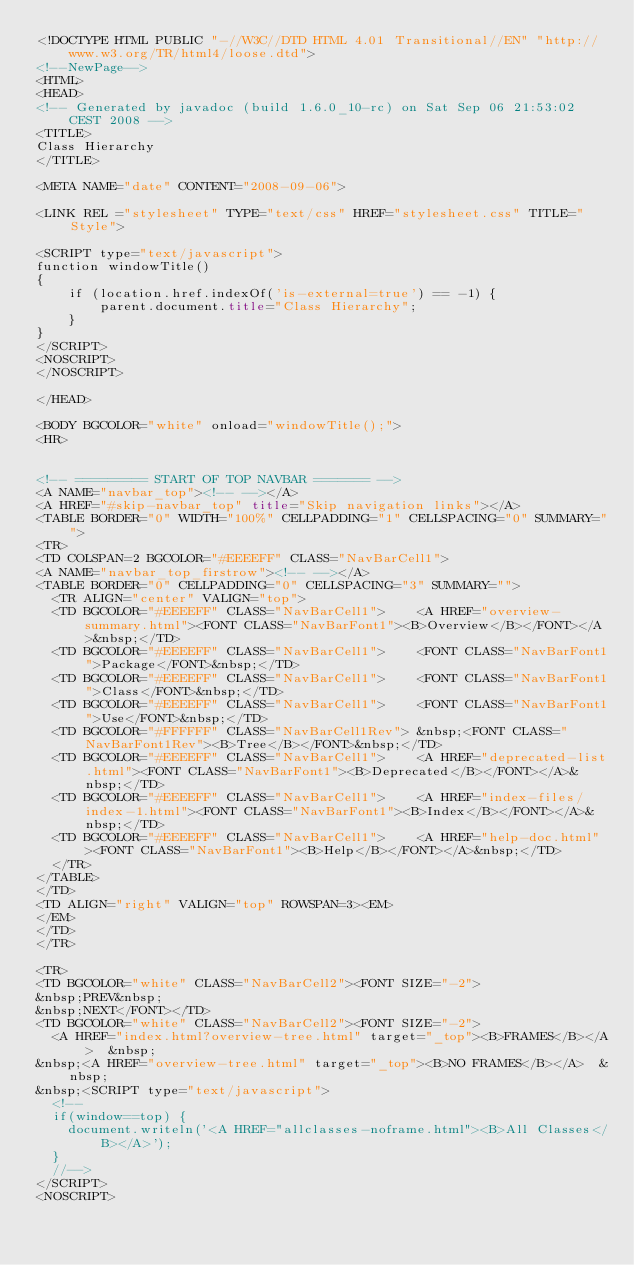Convert code to text. <code><loc_0><loc_0><loc_500><loc_500><_HTML_><!DOCTYPE HTML PUBLIC "-//W3C//DTD HTML 4.01 Transitional//EN" "http://www.w3.org/TR/html4/loose.dtd">
<!--NewPage-->
<HTML>
<HEAD>
<!-- Generated by javadoc (build 1.6.0_10-rc) on Sat Sep 06 21:53:02 CEST 2008 -->
<TITLE>
Class Hierarchy
</TITLE>

<META NAME="date" CONTENT="2008-09-06">

<LINK REL ="stylesheet" TYPE="text/css" HREF="stylesheet.css" TITLE="Style">

<SCRIPT type="text/javascript">
function windowTitle()
{
    if (location.href.indexOf('is-external=true') == -1) {
        parent.document.title="Class Hierarchy";
    }
}
</SCRIPT>
<NOSCRIPT>
</NOSCRIPT>

</HEAD>

<BODY BGCOLOR="white" onload="windowTitle();">
<HR>


<!-- ========= START OF TOP NAVBAR ======= -->
<A NAME="navbar_top"><!-- --></A>
<A HREF="#skip-navbar_top" title="Skip navigation links"></A>
<TABLE BORDER="0" WIDTH="100%" CELLPADDING="1" CELLSPACING="0" SUMMARY="">
<TR>
<TD COLSPAN=2 BGCOLOR="#EEEEFF" CLASS="NavBarCell1">
<A NAME="navbar_top_firstrow"><!-- --></A>
<TABLE BORDER="0" CELLPADDING="0" CELLSPACING="3" SUMMARY="">
  <TR ALIGN="center" VALIGN="top">
  <TD BGCOLOR="#EEEEFF" CLASS="NavBarCell1">    <A HREF="overview-summary.html"><FONT CLASS="NavBarFont1"><B>Overview</B></FONT></A>&nbsp;</TD>
  <TD BGCOLOR="#EEEEFF" CLASS="NavBarCell1">    <FONT CLASS="NavBarFont1">Package</FONT>&nbsp;</TD>
  <TD BGCOLOR="#EEEEFF" CLASS="NavBarCell1">    <FONT CLASS="NavBarFont1">Class</FONT>&nbsp;</TD>
  <TD BGCOLOR="#EEEEFF" CLASS="NavBarCell1">    <FONT CLASS="NavBarFont1">Use</FONT>&nbsp;</TD>
  <TD BGCOLOR="#FFFFFF" CLASS="NavBarCell1Rev"> &nbsp;<FONT CLASS="NavBarFont1Rev"><B>Tree</B></FONT>&nbsp;</TD>
  <TD BGCOLOR="#EEEEFF" CLASS="NavBarCell1">    <A HREF="deprecated-list.html"><FONT CLASS="NavBarFont1"><B>Deprecated</B></FONT></A>&nbsp;</TD>
  <TD BGCOLOR="#EEEEFF" CLASS="NavBarCell1">    <A HREF="index-files/index-1.html"><FONT CLASS="NavBarFont1"><B>Index</B></FONT></A>&nbsp;</TD>
  <TD BGCOLOR="#EEEEFF" CLASS="NavBarCell1">    <A HREF="help-doc.html"><FONT CLASS="NavBarFont1"><B>Help</B></FONT></A>&nbsp;</TD>
  </TR>
</TABLE>
</TD>
<TD ALIGN="right" VALIGN="top" ROWSPAN=3><EM>
</EM>
</TD>
</TR>

<TR>
<TD BGCOLOR="white" CLASS="NavBarCell2"><FONT SIZE="-2">
&nbsp;PREV&nbsp;
&nbsp;NEXT</FONT></TD>
<TD BGCOLOR="white" CLASS="NavBarCell2"><FONT SIZE="-2">
  <A HREF="index.html?overview-tree.html" target="_top"><B>FRAMES</B></A>  &nbsp;
&nbsp;<A HREF="overview-tree.html" target="_top"><B>NO FRAMES</B></A>  &nbsp;
&nbsp;<SCRIPT type="text/javascript">
  <!--
  if(window==top) {
    document.writeln('<A HREF="allclasses-noframe.html"><B>All Classes</B></A>');
  }
  //-->
</SCRIPT>
<NOSCRIPT></code> 